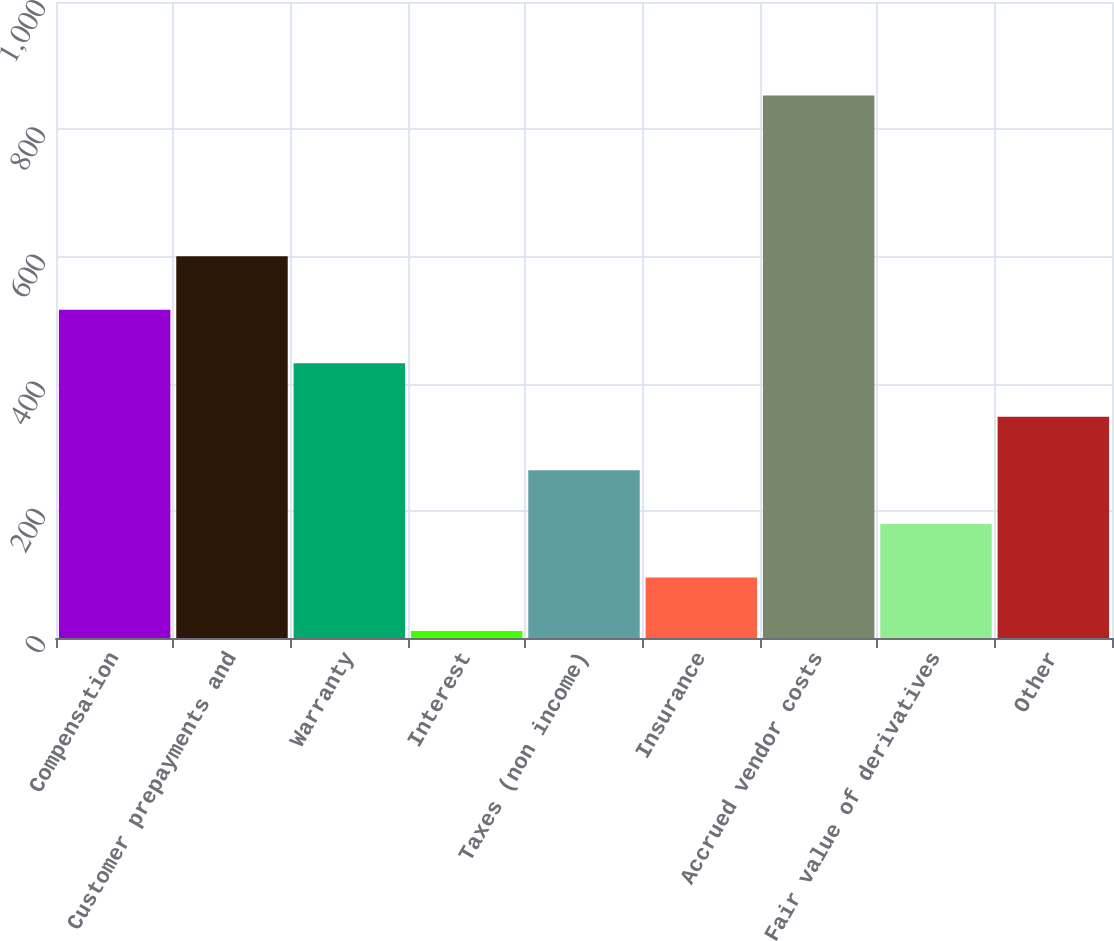Convert chart to OTSL. <chart><loc_0><loc_0><loc_500><loc_500><bar_chart><fcel>Compensation<fcel>Customer prepayments and<fcel>Warranty<fcel>Interest<fcel>Taxes (non income)<fcel>Insurance<fcel>Accrued vendor costs<fcel>Fair value of derivatives<fcel>Other<nl><fcel>516.2<fcel>600.4<fcel>432<fcel>11<fcel>263.6<fcel>95.2<fcel>853<fcel>179.4<fcel>347.8<nl></chart> 